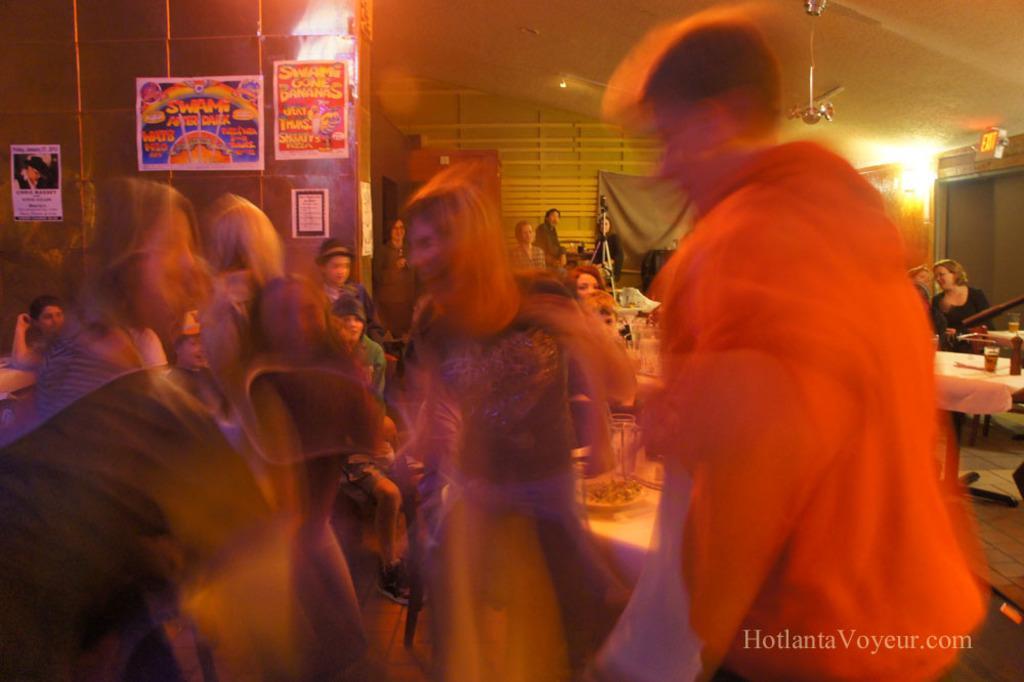Please provide a concise description of this image. In this picture we can see so many people are in one place and we can see some tables, on which we can see some glasses, bottles are placed, behind we can see some posters to the wall. 